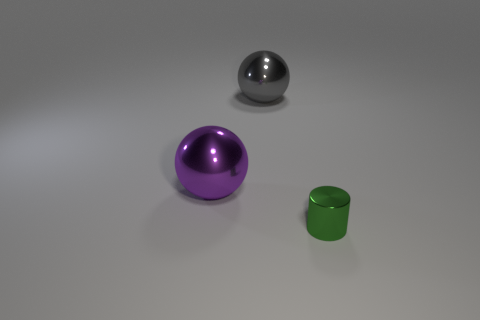Is the purple ball the same size as the green cylinder?
Provide a short and direct response. No. What number of other things are there of the same size as the purple thing?
Provide a succinct answer. 1. What number of things are spheres that are on the left side of the large gray sphere or metallic objects left of the small green shiny thing?
Provide a short and direct response. 2. There is a purple ball that is made of the same material as the gray sphere; what size is it?
Provide a short and direct response. Large. Do the green shiny thing and the large gray metal object have the same shape?
Give a very brief answer. No. What is the color of the other metallic thing that is the same size as the gray thing?
Your answer should be compact. Purple. There is a gray object that is the same shape as the large purple object; what is its size?
Ensure brevity in your answer.  Large. What shape is the big metallic object on the left side of the big gray object?
Offer a terse response. Sphere. There is a large gray thing; does it have the same shape as the shiny thing to the right of the gray metallic sphere?
Make the answer very short. No. Are there the same number of big purple balls in front of the large purple sphere and big purple metallic things that are in front of the small green cylinder?
Keep it short and to the point. Yes. 